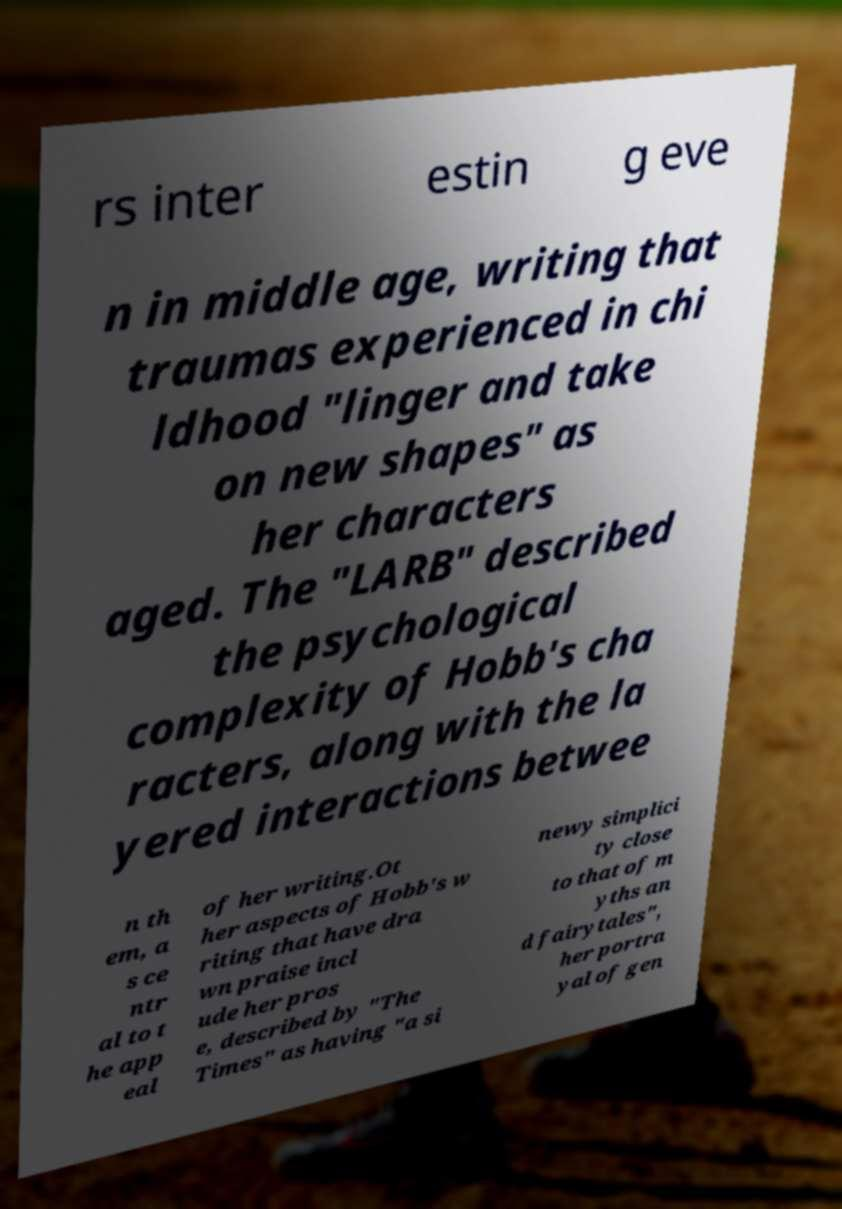I need the written content from this picture converted into text. Can you do that? rs inter estin g eve n in middle age, writing that traumas experienced in chi ldhood "linger and take on new shapes" as her characters aged. The "LARB" described the psychological complexity of Hobb's cha racters, along with the la yered interactions betwee n th em, a s ce ntr al to t he app eal of her writing.Ot her aspects of Hobb's w riting that have dra wn praise incl ude her pros e, described by "The Times" as having "a si newy simplici ty close to that of m yths an d fairytales", her portra yal of gen 